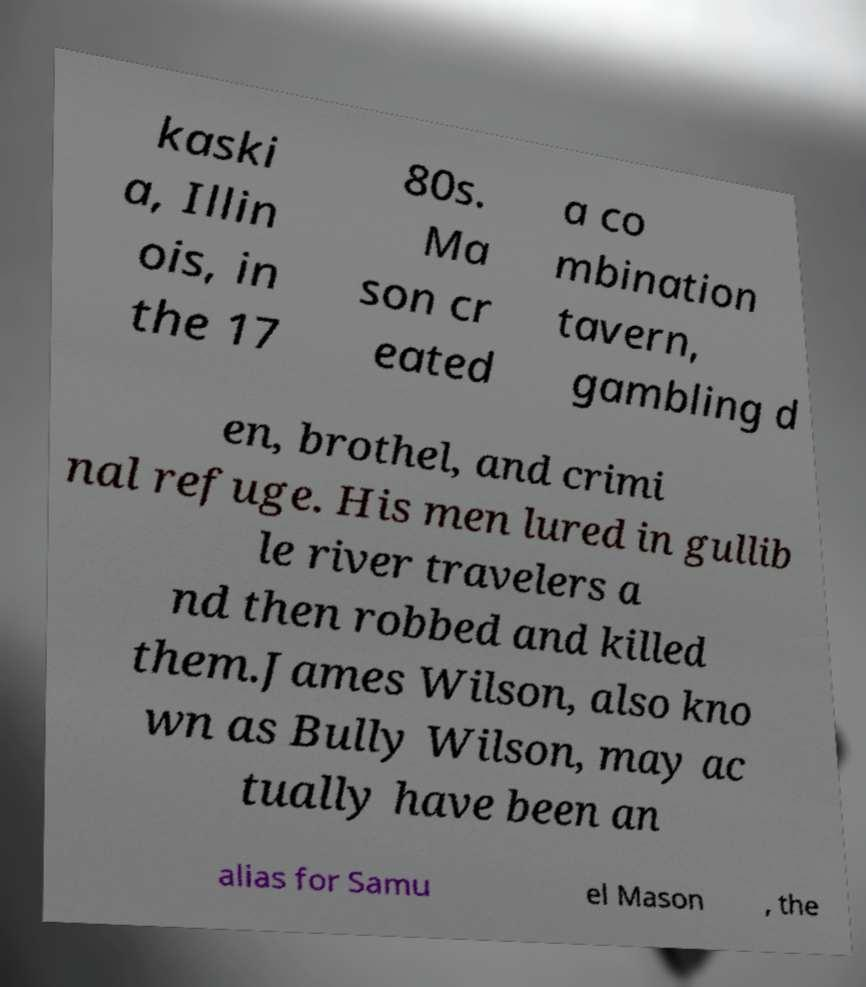For documentation purposes, I need the text within this image transcribed. Could you provide that? kaski a, Illin ois, in the 17 80s. Ma son cr eated a co mbination tavern, gambling d en, brothel, and crimi nal refuge. His men lured in gullib le river travelers a nd then robbed and killed them.James Wilson, also kno wn as Bully Wilson, may ac tually have been an alias for Samu el Mason , the 